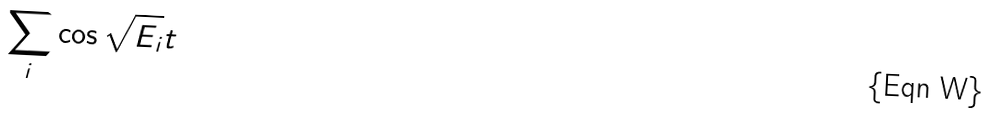<formula> <loc_0><loc_0><loc_500><loc_500>\sum _ { i } \cos \sqrt { E _ { i } } t</formula> 